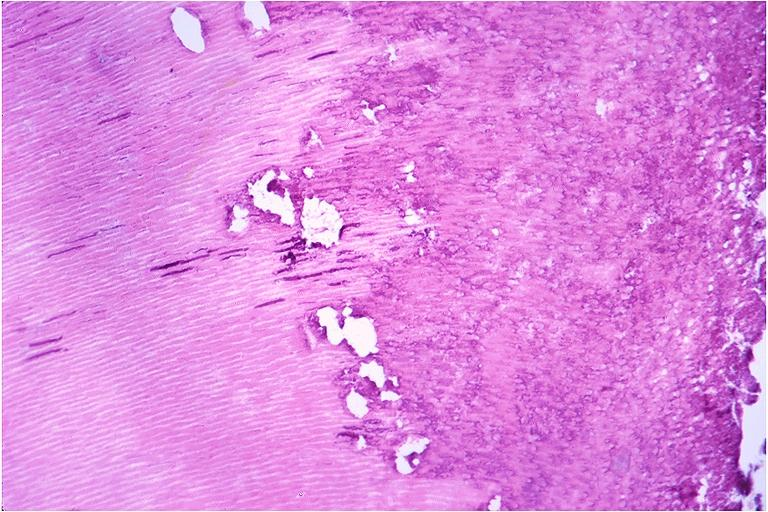does this image show caries?
Answer the question using a single word or phrase. Yes 